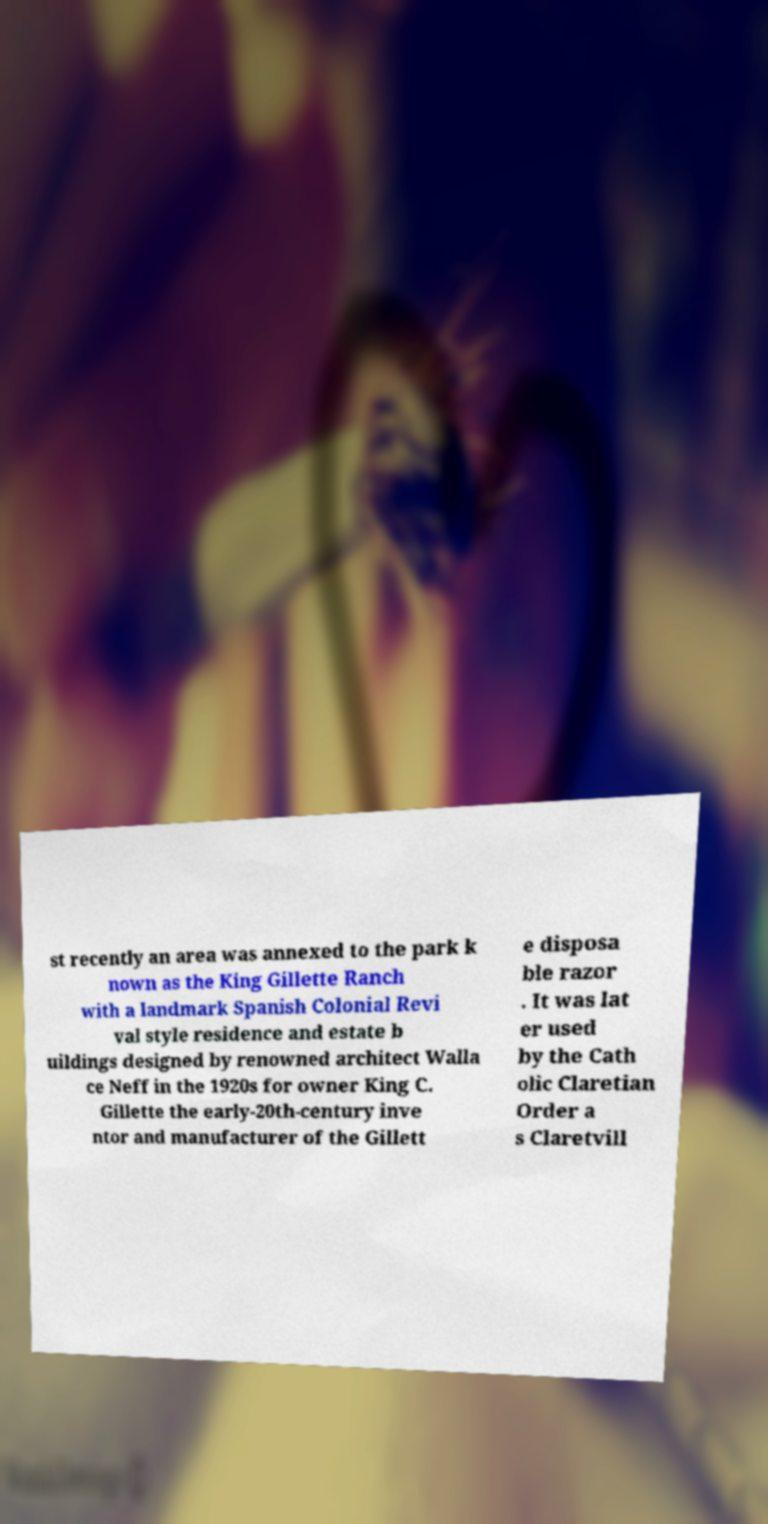Could you extract and type out the text from this image? st recently an area was annexed to the park k nown as the King Gillette Ranch with a landmark Spanish Colonial Revi val style residence and estate b uildings designed by renowned architect Walla ce Neff in the 1920s for owner King C. Gillette the early-20th-century inve ntor and manufacturer of the Gillett e disposa ble razor . It was lat er used by the Cath olic Claretian Order a s Claretvill 